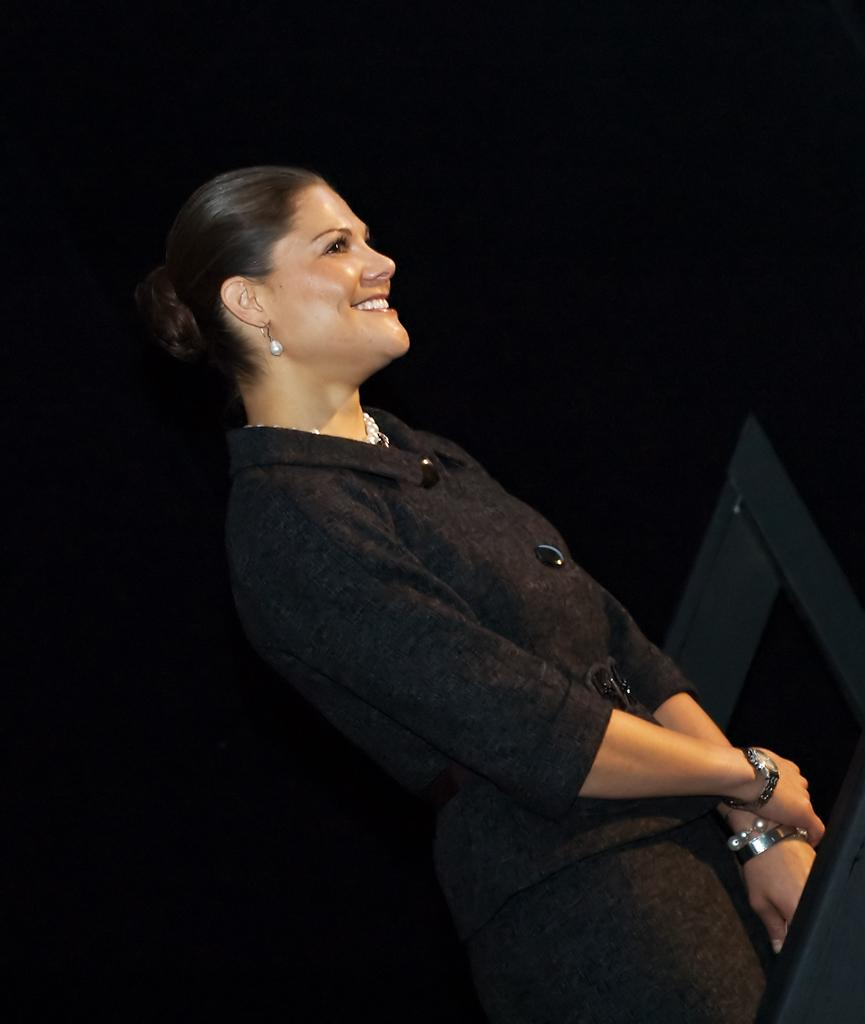Who is the main subject in the image? There is a woman in the image. What is the woman wearing? The woman is wearing a black dress. What is the woman doing in the image? The woman is standing and smiling. What color is the background of the image? The background of the image is black. What type of pipe can be seen in the woman's hand in the image? There is no pipe present in the image; the woman is not holding anything. 